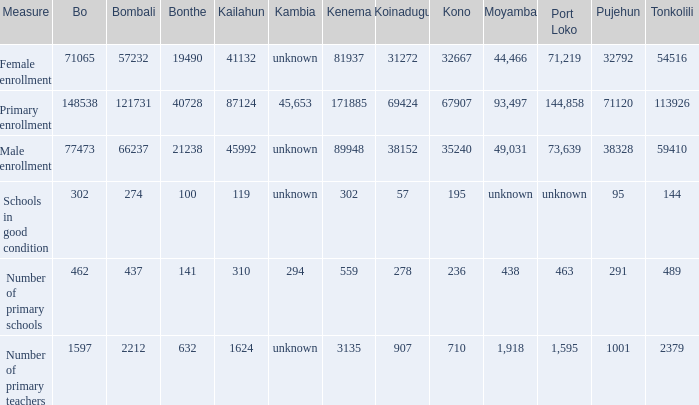What is the lowest number associated with Tonkolili? 144.0. 